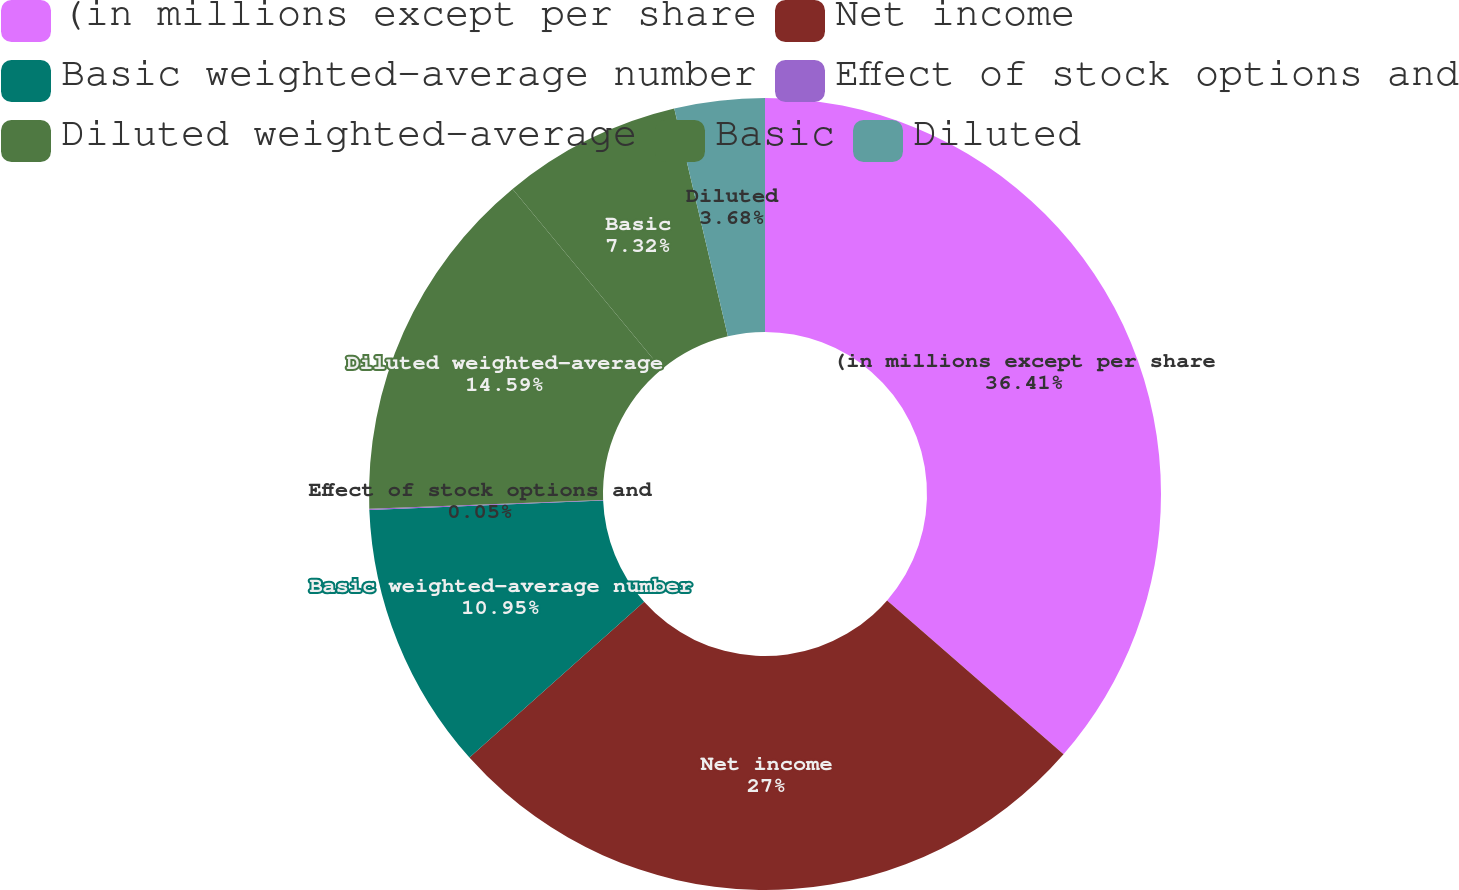Convert chart to OTSL. <chart><loc_0><loc_0><loc_500><loc_500><pie_chart><fcel>(in millions except per share<fcel>Net income<fcel>Basic weighted-average number<fcel>Effect of stock options and<fcel>Diluted weighted-average<fcel>Basic<fcel>Diluted<nl><fcel>36.41%<fcel>27.0%<fcel>10.95%<fcel>0.05%<fcel>14.59%<fcel>7.32%<fcel>3.68%<nl></chart> 